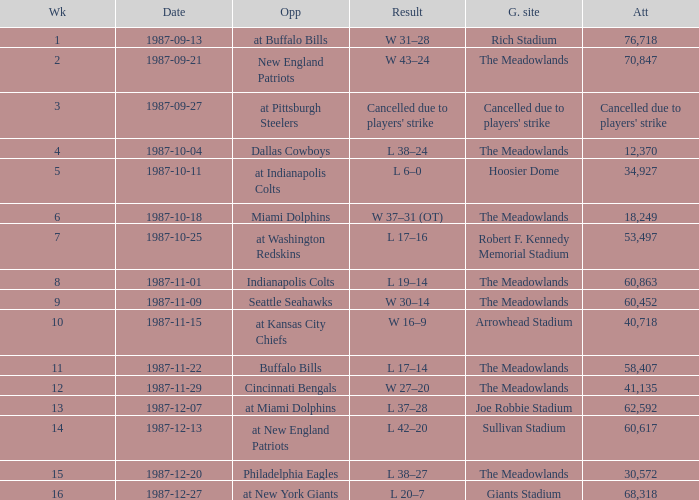Who did the Jets play in their pre-week 9 game at the Robert F. Kennedy memorial stadium? At washington redskins. Can you give me this table as a dict? {'header': ['Wk', 'Date', 'Opp', 'Result', 'G. site', 'Att'], 'rows': [['1', '1987-09-13', 'at Buffalo Bills', 'W 31–28', 'Rich Stadium', '76,718'], ['2', '1987-09-21', 'New England Patriots', 'W 43–24', 'The Meadowlands', '70,847'], ['3', '1987-09-27', 'at Pittsburgh Steelers', "Cancelled due to players' strike", "Cancelled due to players' strike", "Cancelled due to players' strike"], ['4', '1987-10-04', 'Dallas Cowboys', 'L 38–24', 'The Meadowlands', '12,370'], ['5', '1987-10-11', 'at Indianapolis Colts', 'L 6–0', 'Hoosier Dome', '34,927'], ['6', '1987-10-18', 'Miami Dolphins', 'W 37–31 (OT)', 'The Meadowlands', '18,249'], ['7', '1987-10-25', 'at Washington Redskins', 'L 17–16', 'Robert F. Kennedy Memorial Stadium', '53,497'], ['8', '1987-11-01', 'Indianapolis Colts', 'L 19–14', 'The Meadowlands', '60,863'], ['9', '1987-11-09', 'Seattle Seahawks', 'W 30–14', 'The Meadowlands', '60,452'], ['10', '1987-11-15', 'at Kansas City Chiefs', 'W 16–9', 'Arrowhead Stadium', '40,718'], ['11', '1987-11-22', 'Buffalo Bills', 'L 17–14', 'The Meadowlands', '58,407'], ['12', '1987-11-29', 'Cincinnati Bengals', 'W 27–20', 'The Meadowlands', '41,135'], ['13', '1987-12-07', 'at Miami Dolphins', 'L 37–28', 'Joe Robbie Stadium', '62,592'], ['14', '1987-12-13', 'at New England Patriots', 'L 42–20', 'Sullivan Stadium', '60,617'], ['15', '1987-12-20', 'Philadelphia Eagles', 'L 38–27', 'The Meadowlands', '30,572'], ['16', '1987-12-27', 'at New York Giants', 'L 20–7', 'Giants Stadium', '68,318']]} 